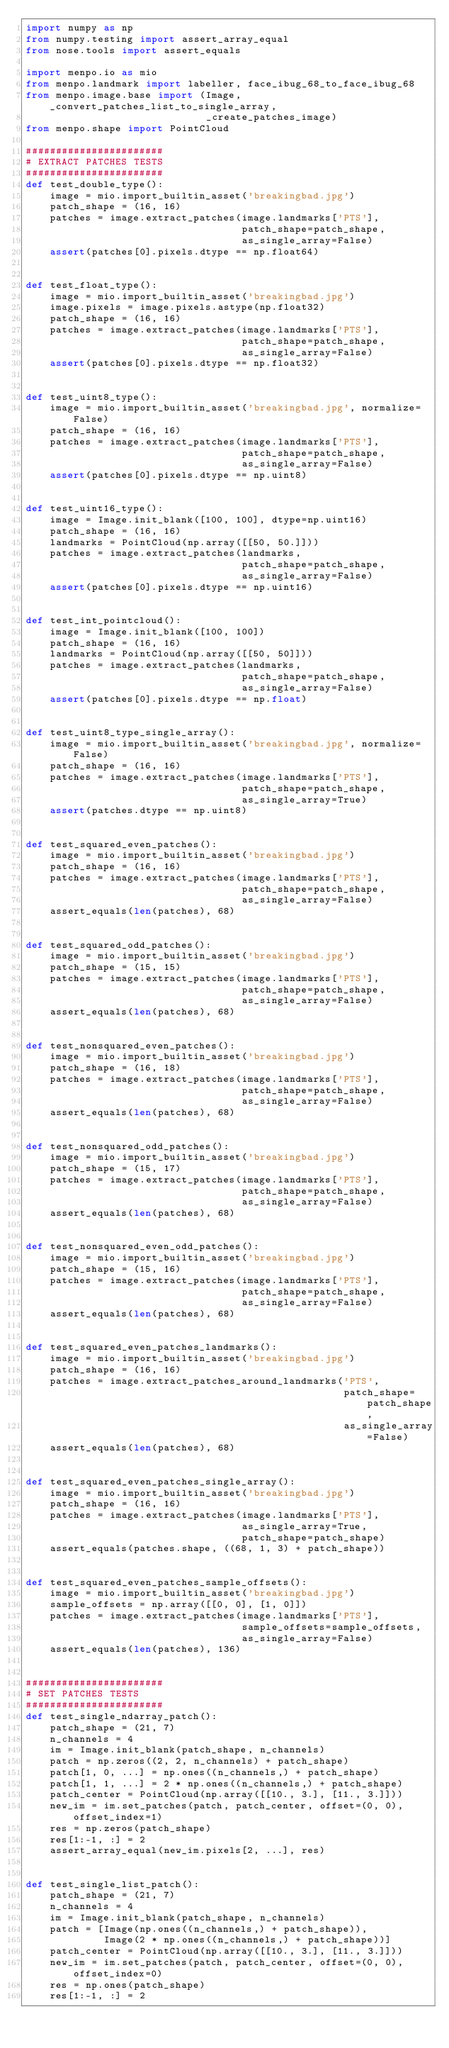<code> <loc_0><loc_0><loc_500><loc_500><_Python_>import numpy as np
from numpy.testing import assert_array_equal
from nose.tools import assert_equals

import menpo.io as mio
from menpo.landmark import labeller, face_ibug_68_to_face_ibug_68
from menpo.image.base import (Image, _convert_patches_list_to_single_array,
                              _create_patches_image)
from menpo.shape import PointCloud

#######################
# EXTRACT PATCHES TESTS
#######################
def test_double_type():
    image = mio.import_builtin_asset('breakingbad.jpg')
    patch_shape = (16, 16)
    patches = image.extract_patches(image.landmarks['PTS'],
                                    patch_shape=patch_shape,
                                    as_single_array=False)
    assert(patches[0].pixels.dtype == np.float64)


def test_float_type():
    image = mio.import_builtin_asset('breakingbad.jpg')
    image.pixels = image.pixels.astype(np.float32)
    patch_shape = (16, 16)
    patches = image.extract_patches(image.landmarks['PTS'],
                                    patch_shape=patch_shape,
                                    as_single_array=False)
    assert(patches[0].pixels.dtype == np.float32)


def test_uint8_type():
    image = mio.import_builtin_asset('breakingbad.jpg', normalize=False)
    patch_shape = (16, 16)
    patches = image.extract_patches(image.landmarks['PTS'],
                                    patch_shape=patch_shape,
                                    as_single_array=False)
    assert(patches[0].pixels.dtype == np.uint8)


def test_uint16_type():
    image = Image.init_blank([100, 100], dtype=np.uint16)
    patch_shape = (16, 16)
    landmarks = PointCloud(np.array([[50, 50.]]))
    patches = image.extract_patches(landmarks,
                                    patch_shape=patch_shape,
                                    as_single_array=False)
    assert(patches[0].pixels.dtype == np.uint16)


def test_int_pointcloud():
    image = Image.init_blank([100, 100])
    patch_shape = (16, 16)
    landmarks = PointCloud(np.array([[50, 50]]))
    patches = image.extract_patches(landmarks,
                                    patch_shape=patch_shape,
                                    as_single_array=False)
    assert(patches[0].pixels.dtype == np.float)


def test_uint8_type_single_array():
    image = mio.import_builtin_asset('breakingbad.jpg', normalize=False)
    patch_shape = (16, 16)
    patches = image.extract_patches(image.landmarks['PTS'],
                                    patch_shape=patch_shape,
                                    as_single_array=True)
    assert(patches.dtype == np.uint8)


def test_squared_even_patches():
    image = mio.import_builtin_asset('breakingbad.jpg')
    patch_shape = (16, 16)
    patches = image.extract_patches(image.landmarks['PTS'],
                                    patch_shape=patch_shape,
                                    as_single_array=False)
    assert_equals(len(patches), 68)


def test_squared_odd_patches():
    image = mio.import_builtin_asset('breakingbad.jpg')
    patch_shape = (15, 15)
    patches = image.extract_patches(image.landmarks['PTS'],
                                    patch_shape=patch_shape,
                                    as_single_array=False)
    assert_equals(len(patches), 68)


def test_nonsquared_even_patches():
    image = mio.import_builtin_asset('breakingbad.jpg')
    patch_shape = (16, 18)
    patches = image.extract_patches(image.landmarks['PTS'],
                                    patch_shape=patch_shape,
                                    as_single_array=False)
    assert_equals(len(patches), 68)


def test_nonsquared_odd_patches():
    image = mio.import_builtin_asset('breakingbad.jpg')
    patch_shape = (15, 17)
    patches = image.extract_patches(image.landmarks['PTS'],
                                    patch_shape=patch_shape,
                                    as_single_array=False)
    assert_equals(len(patches), 68)


def test_nonsquared_even_odd_patches():
    image = mio.import_builtin_asset('breakingbad.jpg')
    patch_shape = (15, 16)
    patches = image.extract_patches(image.landmarks['PTS'],
                                    patch_shape=patch_shape,
                                    as_single_array=False)
    assert_equals(len(patches), 68)


def test_squared_even_patches_landmarks():
    image = mio.import_builtin_asset('breakingbad.jpg')
    patch_shape = (16, 16)
    patches = image.extract_patches_around_landmarks('PTS',
                                                     patch_shape=patch_shape,
                                                     as_single_array=False)
    assert_equals(len(patches), 68)


def test_squared_even_patches_single_array():
    image = mio.import_builtin_asset('breakingbad.jpg')
    patch_shape = (16, 16)
    patches = image.extract_patches(image.landmarks['PTS'],
                                    as_single_array=True,
                                    patch_shape=patch_shape)
    assert_equals(patches.shape, ((68, 1, 3) + patch_shape))


def test_squared_even_patches_sample_offsets():
    image = mio.import_builtin_asset('breakingbad.jpg')
    sample_offsets = np.array([[0, 0], [1, 0]])
    patches = image.extract_patches(image.landmarks['PTS'],
                                    sample_offsets=sample_offsets,
                                    as_single_array=False)
    assert_equals(len(patches), 136)


#######################
# SET PATCHES TESTS
#######################
def test_single_ndarray_patch():
    patch_shape = (21, 7)
    n_channels = 4
    im = Image.init_blank(patch_shape, n_channels)
    patch = np.zeros((2, 2, n_channels) + patch_shape)
    patch[1, 0, ...] = np.ones((n_channels,) + patch_shape)
    patch[1, 1, ...] = 2 * np.ones((n_channels,) + patch_shape)
    patch_center = PointCloud(np.array([[10., 3.], [11., 3.]]))
    new_im = im.set_patches(patch, patch_center, offset=(0, 0), offset_index=1)
    res = np.zeros(patch_shape)
    res[1:-1, :] = 2
    assert_array_equal(new_im.pixels[2, ...], res)


def test_single_list_patch():
    patch_shape = (21, 7)
    n_channels = 4
    im = Image.init_blank(patch_shape, n_channels)
    patch = [Image(np.ones((n_channels,) + patch_shape)),
             Image(2 * np.ones((n_channels,) + patch_shape))]
    patch_center = PointCloud(np.array([[10., 3.], [11., 3.]]))
    new_im = im.set_patches(patch, patch_center, offset=(0, 0), offset_index=0)
    res = np.ones(patch_shape)
    res[1:-1, :] = 2</code> 